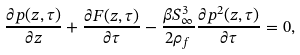Convert formula to latex. <formula><loc_0><loc_0><loc_500><loc_500>\frac { \partial p ( z , \tau ) } { \partial z } + \frac { \partial F ( z , \tau ) } { \partial \tau } - \frac { \beta S _ { \infty } ^ { 3 } } { 2 \rho _ { f } } \frac { \partial p ^ { 2 } ( z , \tau ) } { \partial \tau } = 0 ,</formula> 